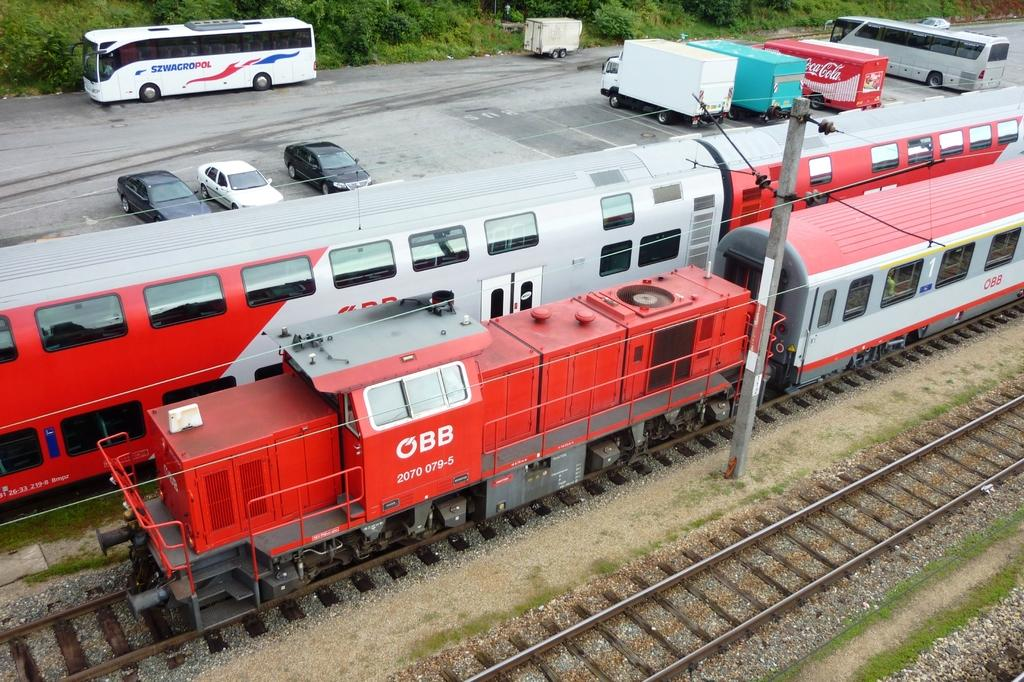What type of transportation can be seen in the image? There are trains in the image. What is the path that the trains are following? There is a rail track in the image. What can be seen beneath the trains and rail track? The ground is visible in the image. What are the vertical structures supporting the wires in the image? There are poles in the image. What are the wires connected to the poles used for? The wires are used for connecting the poles and may be part of an electrical or communication system. What type of natural elements can be seen in the image? There are plants and trees in the image. What type of man-made structure is present in the image? There is a road in the image. What type of vehicles can be seen on the road? There are vehicles in the image. What objects are present on the road? There are objects on the road in the image. Where is the mitten located in the image? There is no mitten present in the image. What type of show can be seen happening in the image? There is no show or performance taking place in the image. 